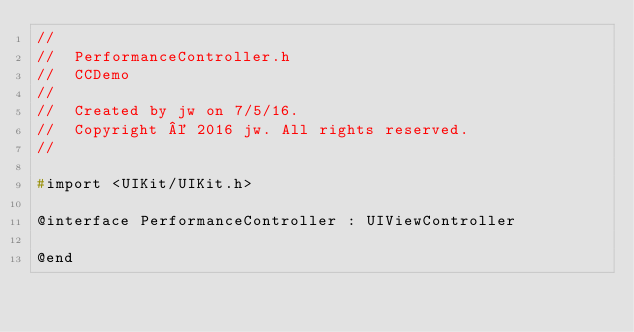Convert code to text. <code><loc_0><loc_0><loc_500><loc_500><_C_>//
//  PerformanceController.h
//  CCDemo
//
//  Created by jw on 7/5/16.
//  Copyright © 2016 jw. All rights reserved.
//

#import <UIKit/UIKit.h>

@interface PerformanceController : UIViewController

@end
</code> 